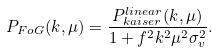<formula> <loc_0><loc_0><loc_500><loc_500>P _ { F o G } ( k , \mu ) = \frac { P ^ { l i n e a r } _ { k a i s e r } ( k , \mu ) } { 1 + f ^ { 2 } k ^ { 2 } \mu ^ { 2 } \sigma _ { v } ^ { 2 } } .</formula> 